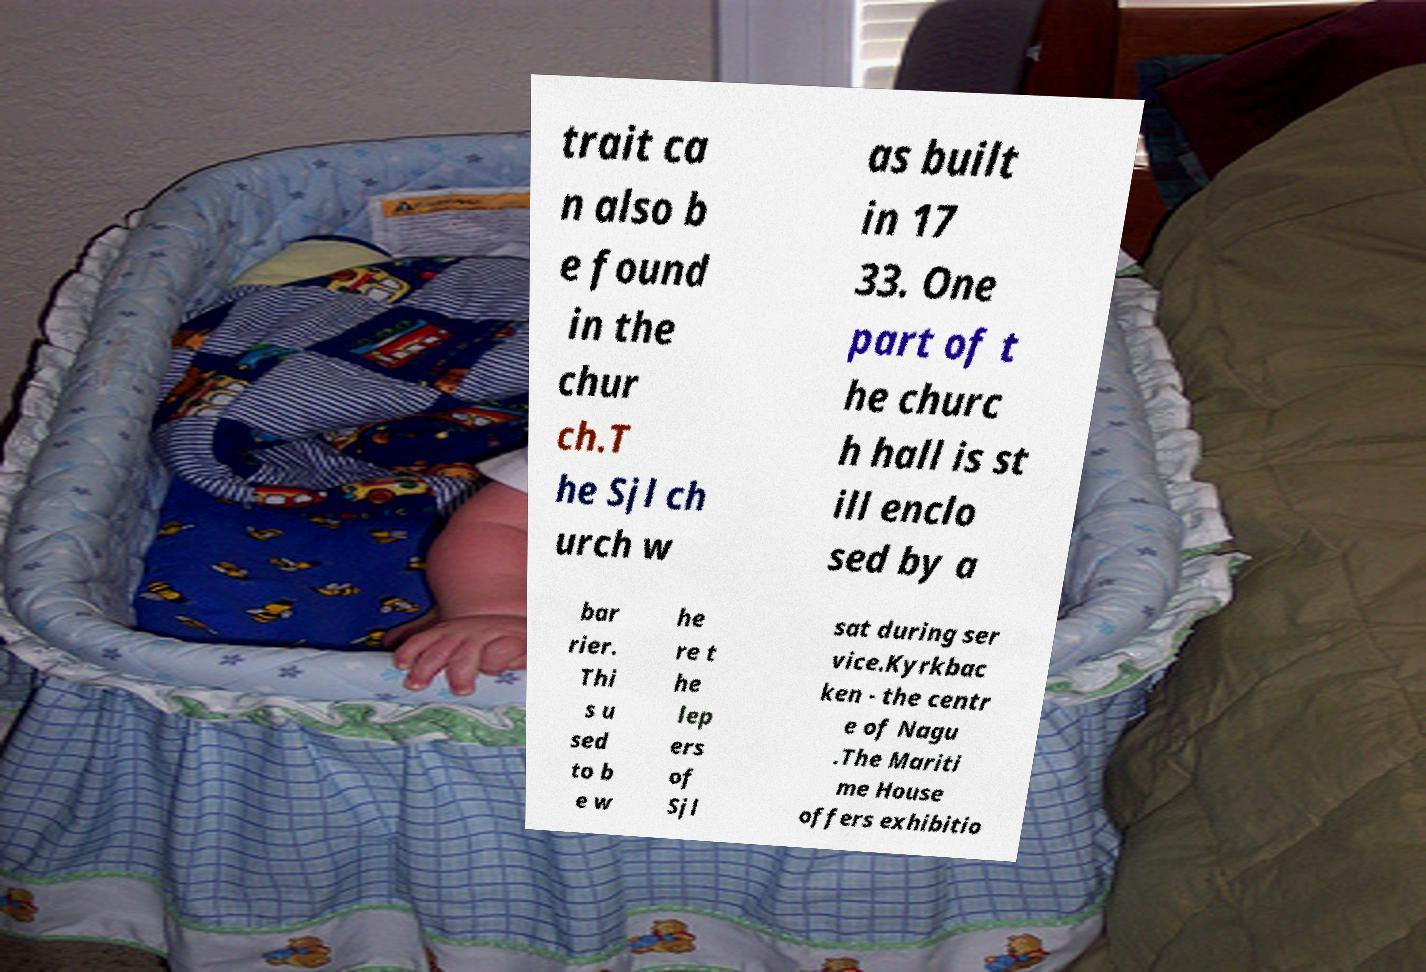Can you accurately transcribe the text from the provided image for me? trait ca n also b e found in the chur ch.T he Sjl ch urch w as built in 17 33. One part of t he churc h hall is st ill enclo sed by a bar rier. Thi s u sed to b e w he re t he lep ers of Sjl sat during ser vice.Kyrkbac ken - the centr e of Nagu .The Mariti me House offers exhibitio 